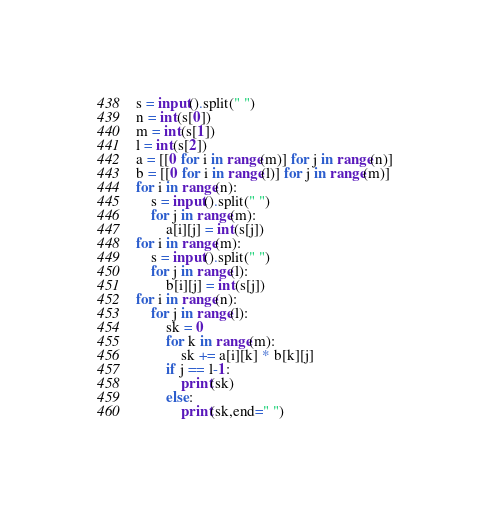Convert code to text. <code><loc_0><loc_0><loc_500><loc_500><_Python_>s = input().split(" ")
n = int(s[0])
m = int(s[1])
l = int(s[2])
a = [[0 for i in range(m)] for j in range(n)]
b = [[0 for i in range(l)] for j in range(m)]
for i in range(n):
    s = input().split(" ")
    for j in range(m):
        a[i][j] = int(s[j])
for i in range(m):
    s = input().split(" ")
    for j in range(l):
        b[i][j] = int(s[j])
for i in range(n):
    for j in range(l):
        sk = 0
        for k in range(m):
            sk += a[i][k] * b[k][j]
        if j == l-1:
            print(sk)
        else:
            print(sk,end=" ")</code> 